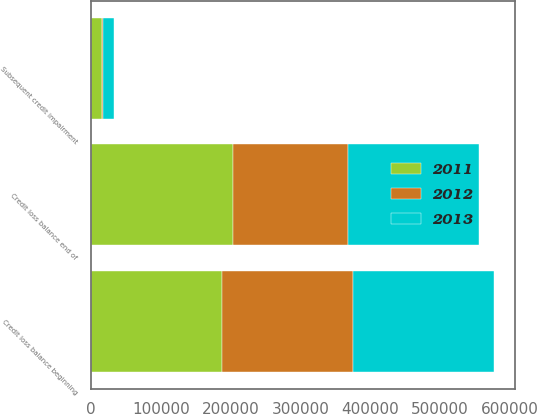Convert chart to OTSL. <chart><loc_0><loc_0><loc_500><loc_500><stacked_bar_chart><ecel><fcel>Credit loss balance beginning<fcel>Subsequent credit impairment<fcel>Credit loss balance end of<nl><fcel>2012<fcel>186722<fcel>2331<fcel>165660<nl><fcel>2013<fcel>202945<fcel>15938<fcel>186722<nl><fcel>2011<fcel>188038<fcel>14846<fcel>202945<nl></chart> 